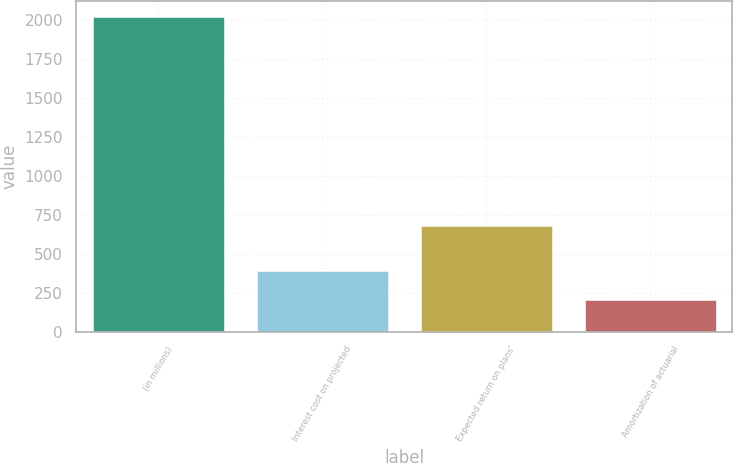Convert chart to OTSL. <chart><loc_0><loc_0><loc_500><loc_500><bar_chart><fcel>(in millions)<fcel>Interest cost on projected<fcel>Expected return on plans'<fcel>Amortization of actuarial<nl><fcel>2018<fcel>386.3<fcel>680<fcel>205<nl></chart> 